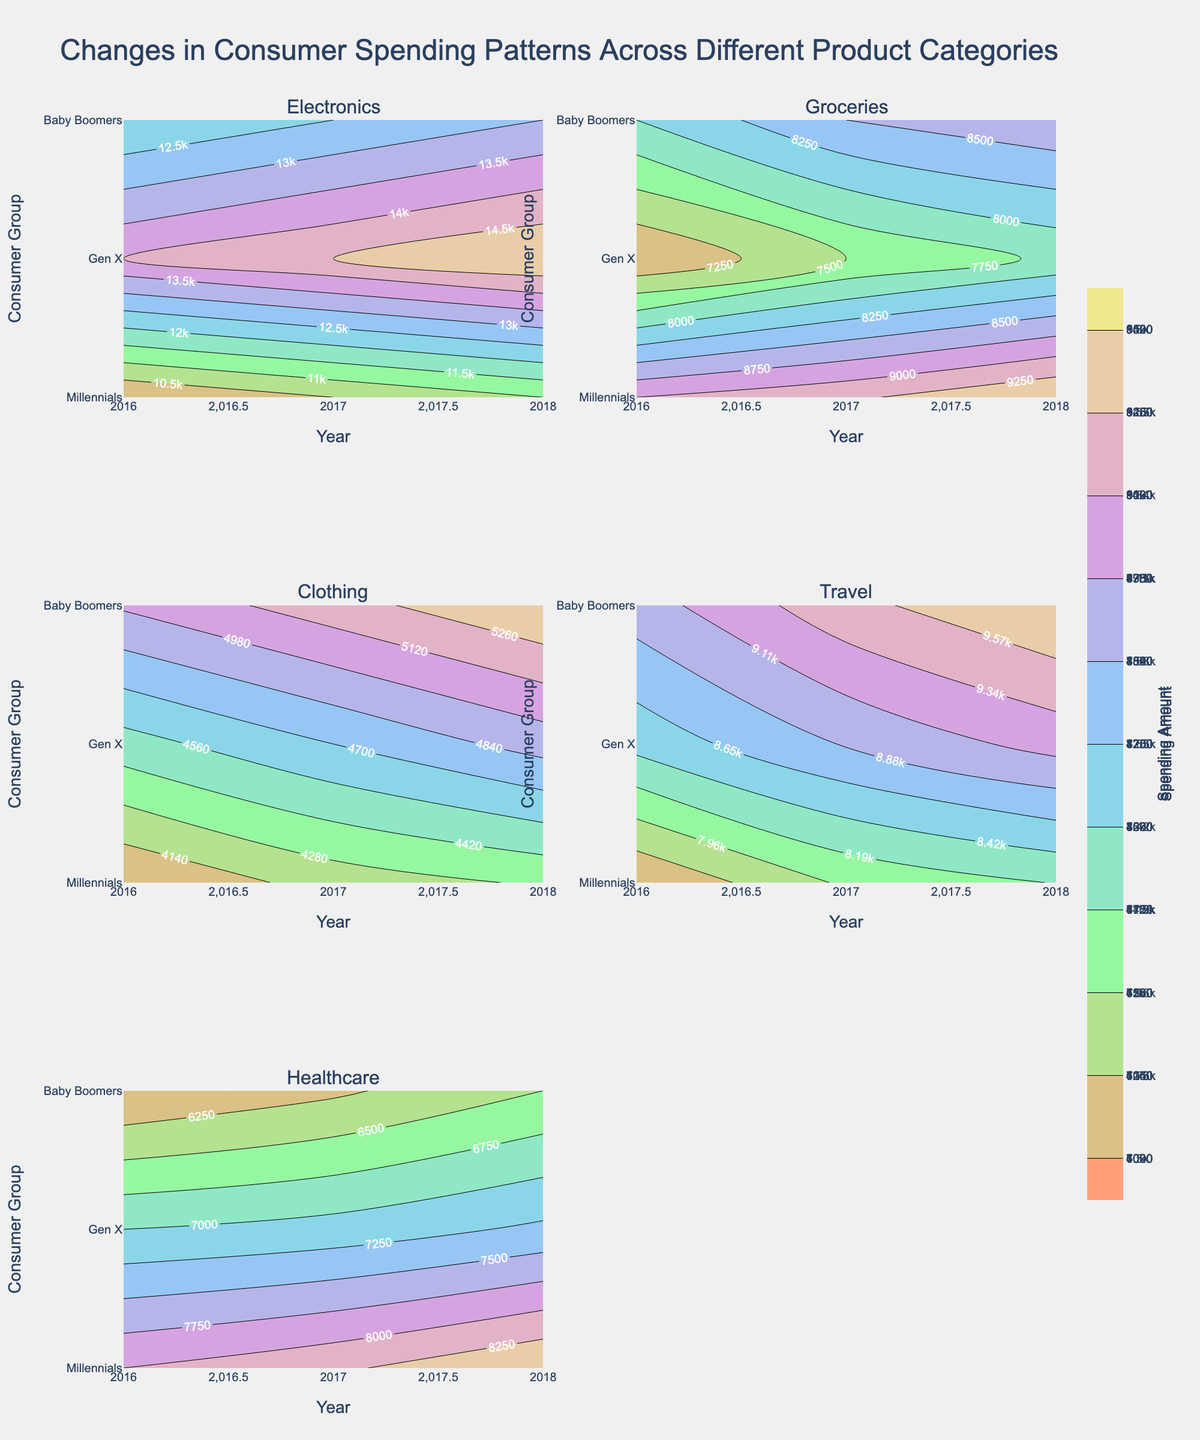What is the title of the figure? The title of the figure is placed at the top and provides an overview of what the plot is depicting.
Answer: Changes in Consumer Spending Patterns Across Different Product Categories How many subplots are there? By counting the individual plots arranged within the main figure, we can identify the number of subplots.
Answer: 6 Which consumer group spends the most on Electronics in 2018? Look at the subplot for Electronics and find the highest contour label in 2018 for each consumer group.
Answer: Gen X What is the spending trend for Baby Boomers in Healthcare from 2016 to 2018? Examine the Healthcare subplot and track the contour labels from 2016 to 2018 for Baby Boomers. Note whether the labels indicate increasing, decreasing, or stable values.
Answer: Increasing How does Millennial spending on Travel in 2017 compare to Gen X spending in the same category and year? Locate the Travel subplot and compare the contour labels for 2017 between Millennials and Gen X.
Answer: Millennials spend more What is the most noticeable spending pattern for Groceries between 2016 and 2018? Use the Groceries subplot to observe any noticeable trends or patterns, such as consistent increases or decreases, prominent differences between consumer groups, etc.
Answer: Baby Boomers consistently spend the most Across all categories, which year shows the highest spending for Millennials? Check the highest contour values for Millennials in each subplot and identify the corresponding year(s) with the peak values.
Answer: 2018 What is the average spending of Baby Boomers on Clothing across 2016 to 2018? Look at the Clothing subplot and note the spending values for Baby Boomers in each year. Calculate their average. (4000 + 4200 + 4300) / 3 = 4166.67.
Answer: 4166.67 Which product category shows the smallest range in spending amounts for Gen X in 2016? Compare the ranges of spending amounts for Gen X in 2016 across all subplots. Identify the category where the difference between the minimum and maximum values is the smallest.
Answer: Clothing In which subplot do the contours show the least variation in spending amounts? Observe the contour lines in each subplot and identify the one with the least differences in values, indicating less variation.
Answer: Groceries 